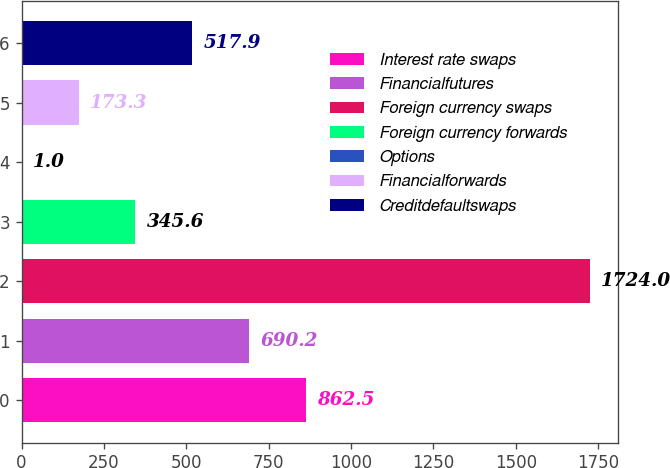<chart> <loc_0><loc_0><loc_500><loc_500><bar_chart><fcel>Interest rate swaps<fcel>Financialfutures<fcel>Foreign currency swaps<fcel>Foreign currency forwards<fcel>Options<fcel>Financialforwards<fcel>Creditdefaultswaps<nl><fcel>862.5<fcel>690.2<fcel>1724<fcel>345.6<fcel>1<fcel>173.3<fcel>517.9<nl></chart> 